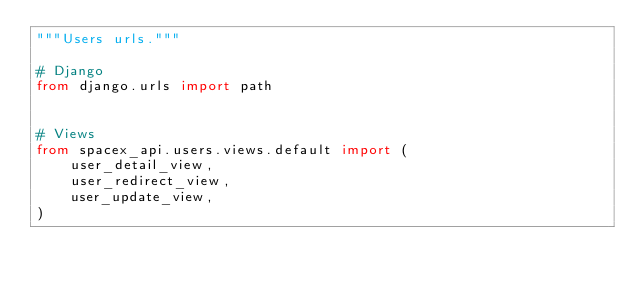Convert code to text. <code><loc_0><loc_0><loc_500><loc_500><_Python_>"""Users urls."""

# Django
from django.urls import path


# Views
from spacex_api.users.views.default import (
    user_detail_view,
    user_redirect_view,
    user_update_view,
)</code> 